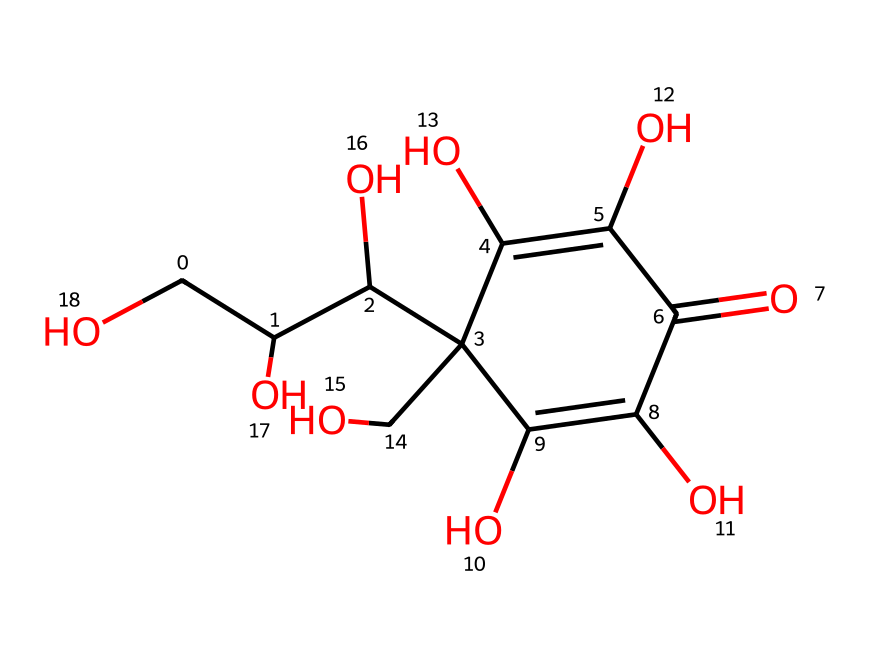What is the molecular formula of vitamin C based on its structure? The molecular formula can be determined by counting the number of each type of atom present in the SMILES representation. In this case, there are 6 carbon (C) atoms, 8 hydrogen (H) atoms, and 6 oxygen (O) atoms. Thus, the molecular formula is C6H8O6.
Answer: C6H8O6 How many hydroxyl (-OH) groups are present in the structure of vitamin C? By analyzing the structure, you can visually identify the hydroxyl groups, which are the -OH functional groups. There are four distinct hydroxyl groups in the structure of vitamin C.
Answer: 4 What is the total number of rings in the molecular structure of vitamin C? Examining the structure reveals that it contains one cyclic part which is a six-membered ring. Therefore, the total number of rings is one.
Answer: 1 Which functional group defines the acidity of vitamin C? The presence of carboxylic acid functional groups (-COOH) in the structure contributes to the acidity of vitamin C. Identifying these specific groups indicated areas that can release a proton, highlighting the acidic nature of the molecule.
Answer: carboxylic acid Is vitamin C an organic or inorganic compound? Based on the presence of carbon atoms and its chemical structure, vitamin C is classified as an organic compound. Organic compounds are primarily characterized by the presence of carbon.
Answer: organic 